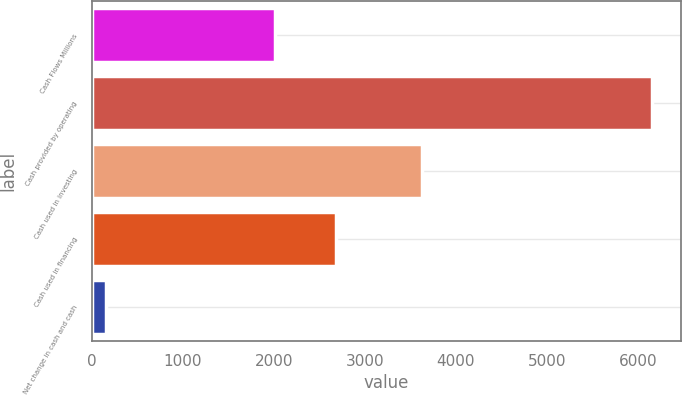<chart> <loc_0><loc_0><loc_500><loc_500><bar_chart><fcel>Cash Flows Millions<fcel>Cash provided by operating<fcel>Cash used in investing<fcel>Cash used in financing<fcel>Net change in cash and cash<nl><fcel>2012<fcel>6161<fcel>3633<fcel>2682<fcel>154<nl></chart> 